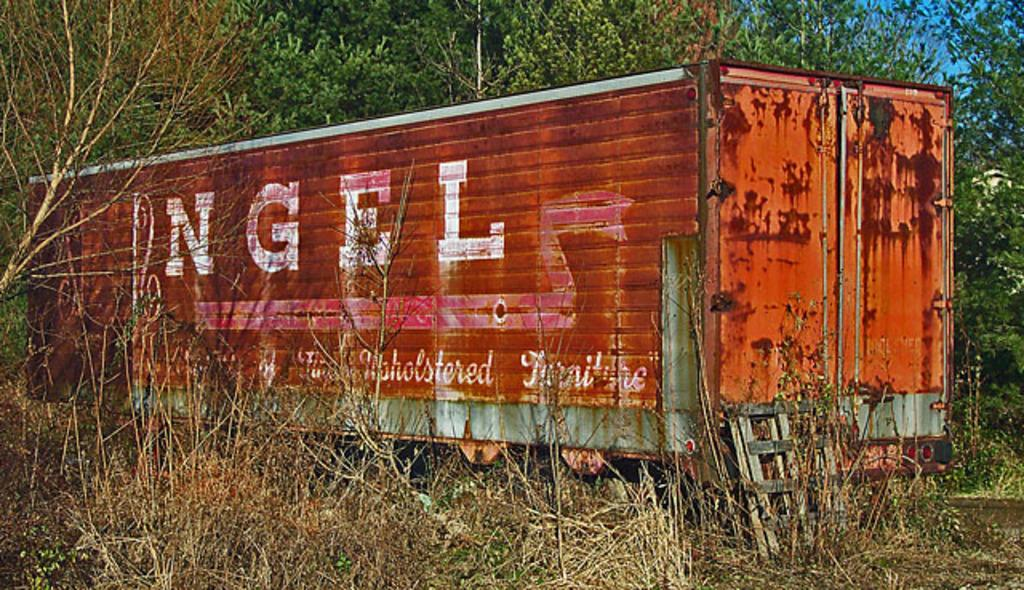What is the main object in the image? There is a container in the image. What type of living organisms can be seen in the image? Plants and trees are visible in the image. Can you describe any other objects in the image? There are unspecified objects in the image. What can be seen in the background of the image? The sky is visible in the background of the image. What type of ornament is hanging from the container in the image? There is no ornament hanging from the container in the image. Can you tell me how many experts are present in the image? There is no expert present in the image. 